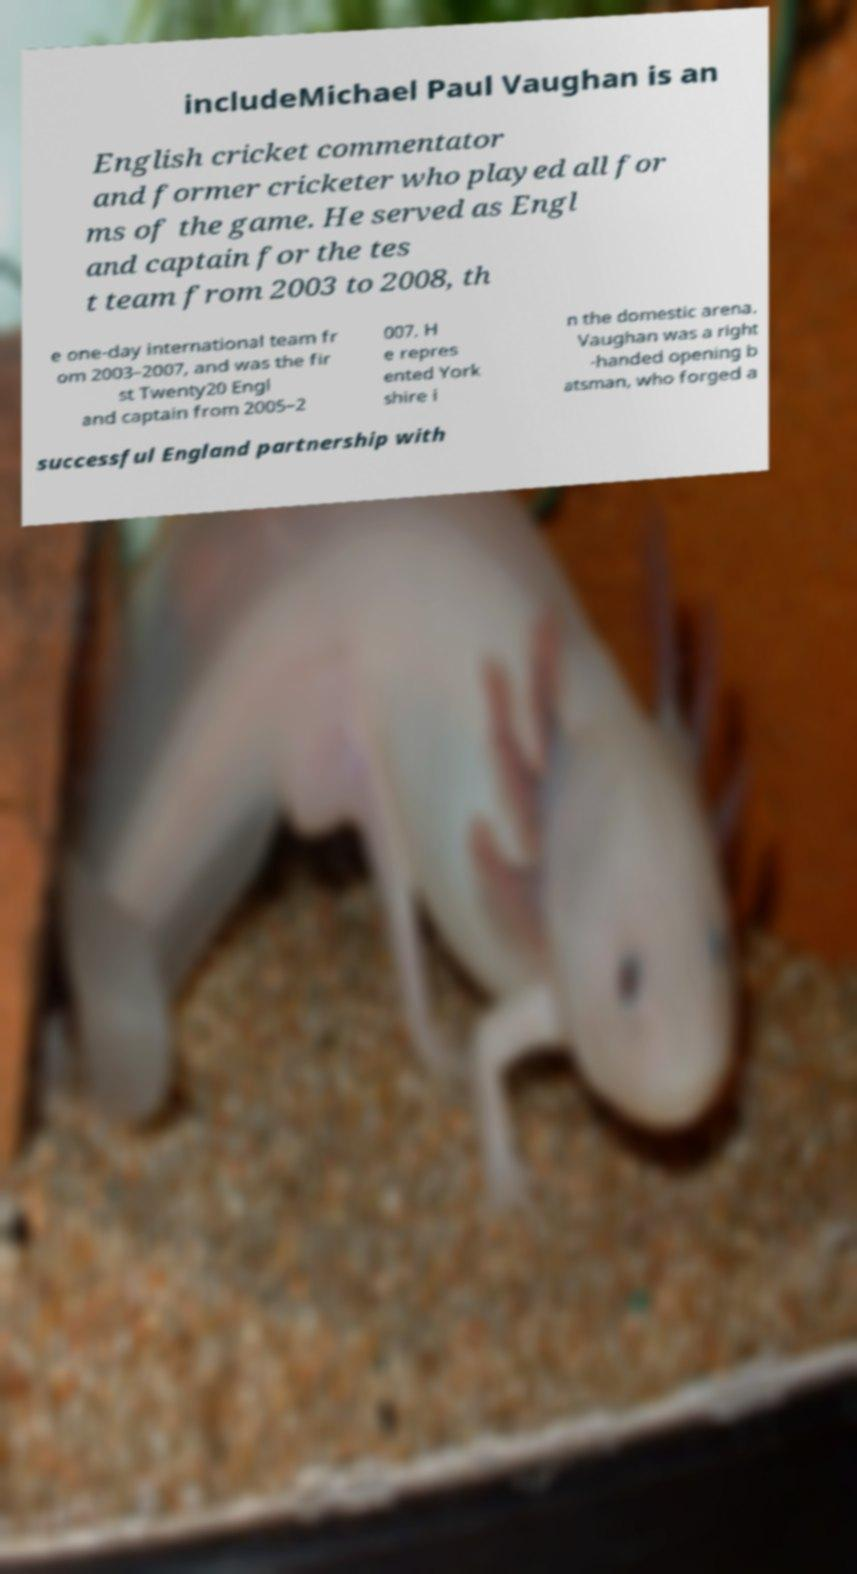Can you read and provide the text displayed in the image?This photo seems to have some interesting text. Can you extract and type it out for me? includeMichael Paul Vaughan is an English cricket commentator and former cricketer who played all for ms of the game. He served as Engl and captain for the tes t team from 2003 to 2008, th e one-day international team fr om 2003–2007, and was the fir st Twenty20 Engl and captain from 2005–2 007. H e repres ented York shire i n the domestic arena. Vaughan was a right -handed opening b atsman, who forged a successful England partnership with 